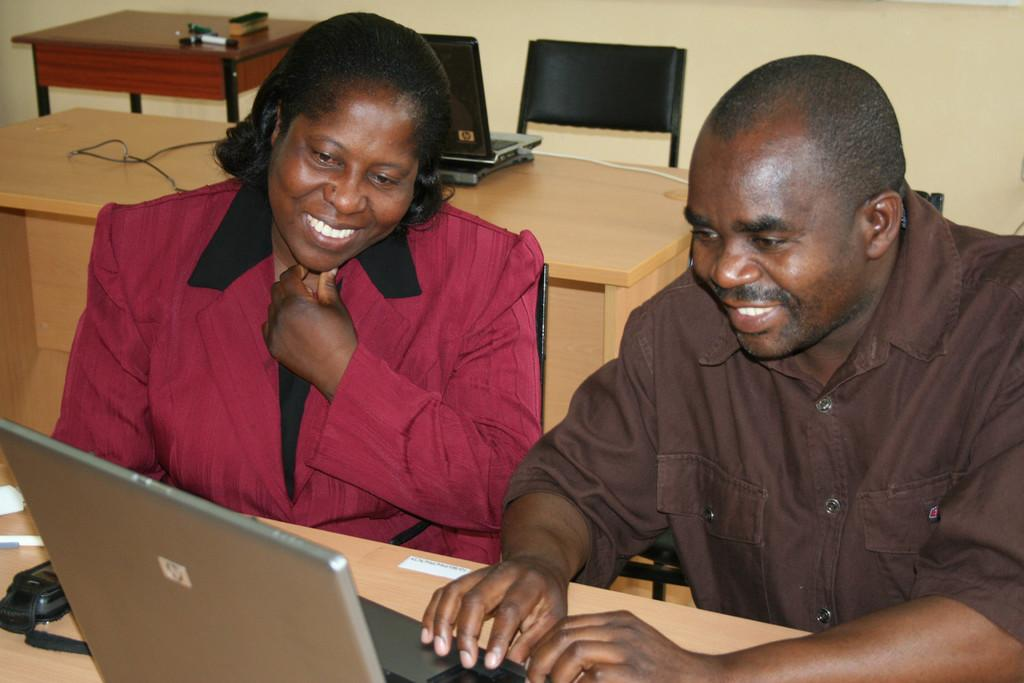What are the people in the image doing? The people in the image are sitting on chairs and operating laptops. What can be seen in the background of the image? There is a table in the background. What is present on the table? Cables and a laptop are present on the table. Where can the rabbits be seen playing in the image? There are no rabbits present in the image. What type of land can be seen in the image? The image does not depict any land; it shows people sitting on chairs and operating laptops. 